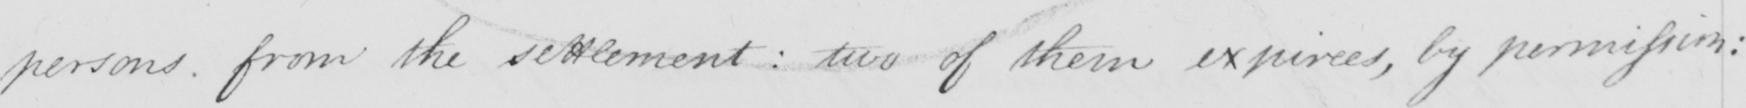Please provide the text content of this handwritten line. persons from the settlement :  two of them expirees , by permission : 